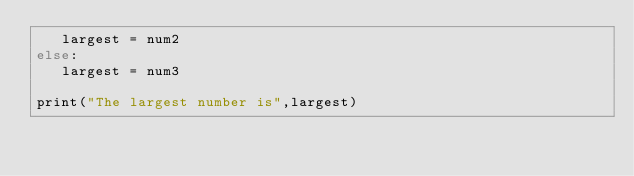<code> <loc_0><loc_0><loc_500><loc_500><_C_>   largest = num2
else:
   largest = num3
 
print("The largest number is",largest)
</code> 